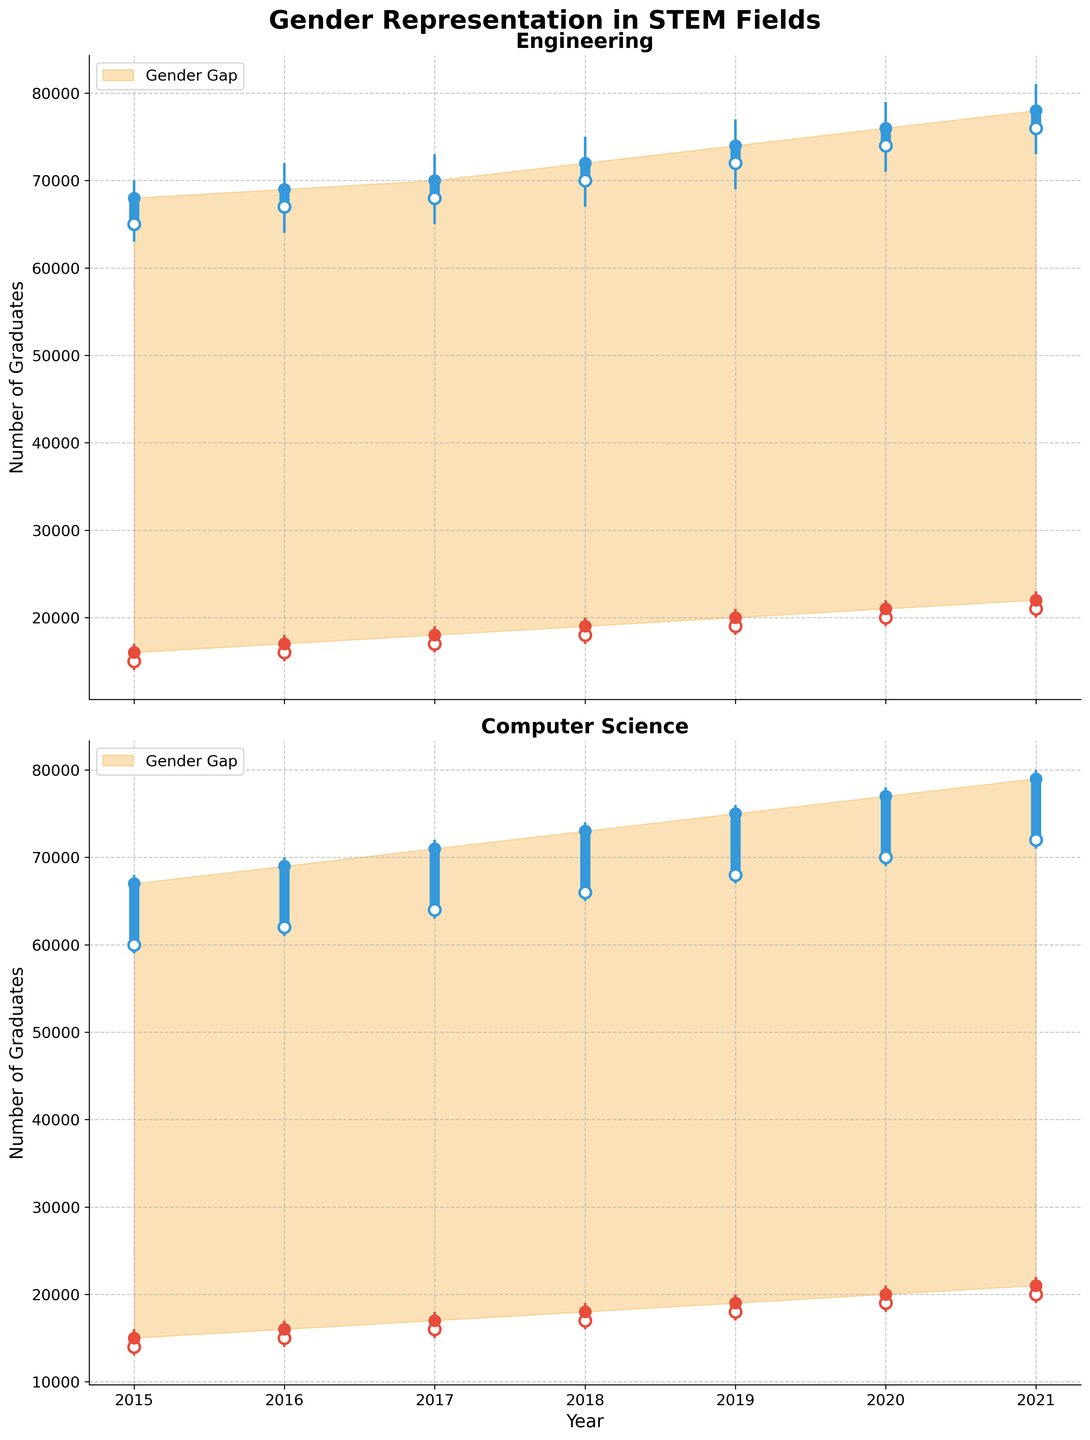what is the title of the plot? The title of the plot is visible at the top and reads "Gender Representation in STEM Fields".
Answer: Gender Representation in STEM Fields what are the fields represented in the plot? The two fields represented in the plot can be identified from the sub-titles of individual charts, "Engineering" and "Computer Science".
Answer: Engineering, Computer Science which gender had more graduates in Engineering in 2021? By observing the vertical candlesticks for 2021 in the "Engineering" section, the larger candlestick representing "Male" shows that males had more graduates in Engineering in 2021.
Answer: Male in which year did the gap between male and female graduates in Computer Science appear the largest? To find the year with the largest gap, we look at the vertical distance between the top of the "Male" candlestick and the top of the "Female" candlestick in the "Computer Science" section and compare them across all years. 2021 shows the largest gap.
Answer: 2021 what was the number of female Computer Science graduates in 2018? By looking at the bottom point of the thicker section of the 2018 "Female" candlestick in the "Computer Science" chart, the number of female graduates can be directly read off, which is 17,000.
Answer: 17,000 in which year did male graduates in Engineering see the highest close value? The highest close value for male graduates in Engineering can be determined by locating the top end of the wide candlestick segments across all years in the "Engineering" chart. The year 2021 shows the highest close value of 78,000.
Answer: 2021 compare the trend of male and female graduates in Engineering over the years. By visually analyzing the trends of the candlestick close values from 2015 to 2021 in the "Engineering" section, both male and female numbers steadily increased, with the male numbers maintaining a consistently higher count than female numbers.
Answer: Both increased steadily, males consistently higher what is the significance of the shaded areas in the plots? The shaded areas in both charts highlight the gender gap between male and female graduate numbers.
Answer: Highlight the gender gap did female graduates in Computer Science increase or decrease from 2015 to 2021? By following the sequence of candlesticks for female graduates in the "Computer Science" section from 2015 to 2021, the trend shows an increase in the number of graduates.
Answer: Increase compare the change in the number of male graduates in Engineering from 2015 to 2020 with that in Computer Science. By examining the widening of the candlestick "open" to "close" markers for male graduates in both "Engineering" and "Computer Science" from 2015 to 2020, Engineering saw a change from 68,000 to 76,000, while Computer Science saw a change from 67,000 to 77,000. Engineering saw an 8,000 increase compared to a 10,000 increase in Computer Science.
Answer: 8,000 in Engineering, 10,000 in Computer Science 